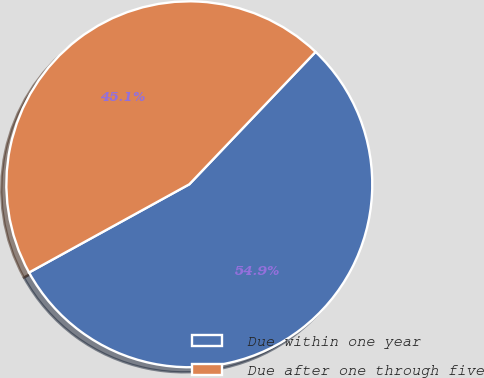<chart> <loc_0><loc_0><loc_500><loc_500><pie_chart><fcel>Due within one year<fcel>Due after one through five<nl><fcel>54.87%<fcel>45.13%<nl></chart> 